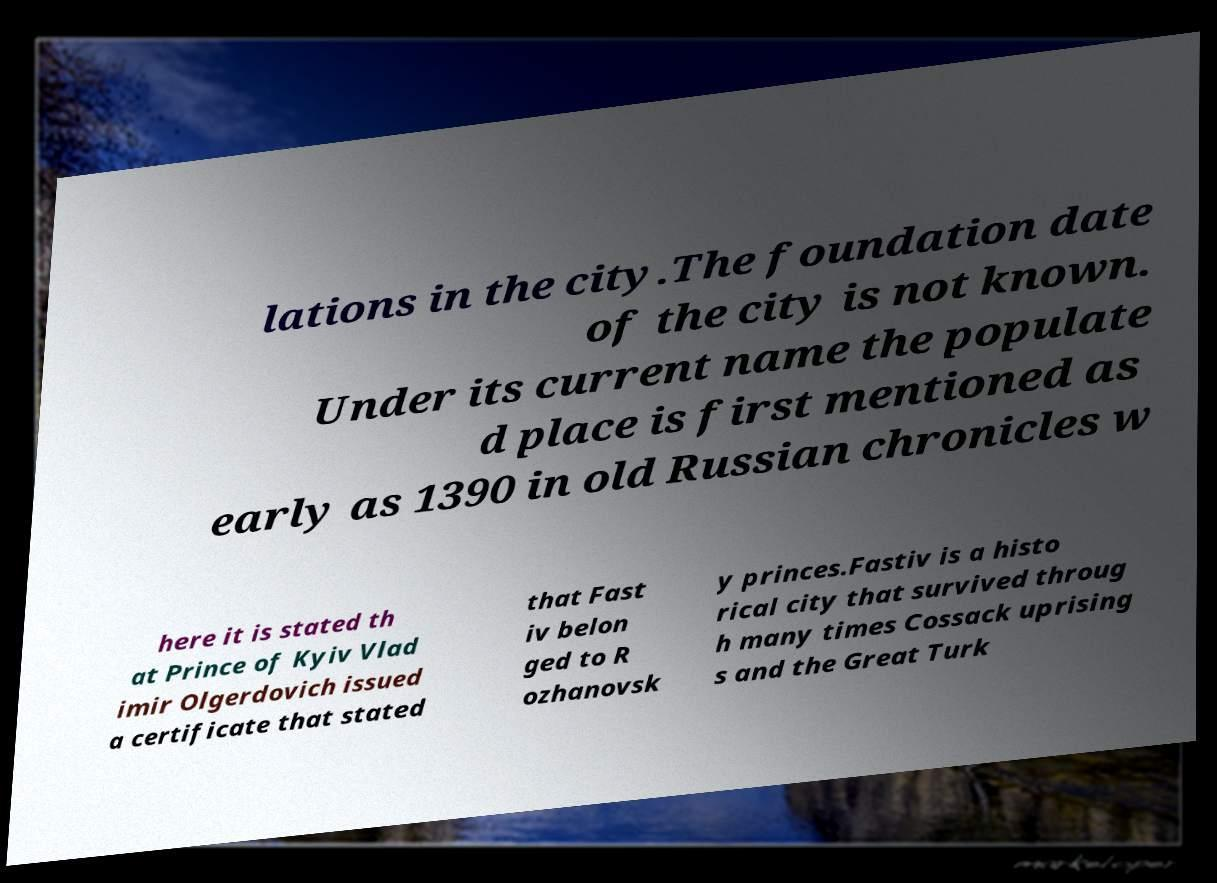Could you assist in decoding the text presented in this image and type it out clearly? lations in the city.The foundation date of the city is not known. Under its current name the populate d place is first mentioned as early as 1390 in old Russian chronicles w here it is stated th at Prince of Kyiv Vlad imir Olgerdovich issued a certificate that stated that Fast iv belon ged to R ozhanovsk y princes.Fastiv is a histo rical city that survived throug h many times Cossack uprising s and the Great Turk 